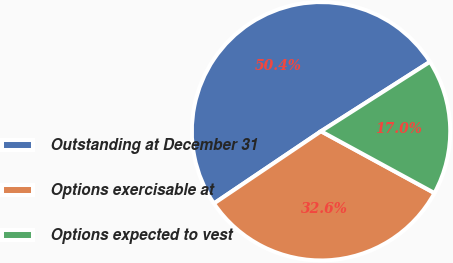<chart> <loc_0><loc_0><loc_500><loc_500><pie_chart><fcel>Outstanding at December 31<fcel>Options exercisable at<fcel>Options expected to vest<nl><fcel>50.41%<fcel>32.62%<fcel>16.97%<nl></chart> 